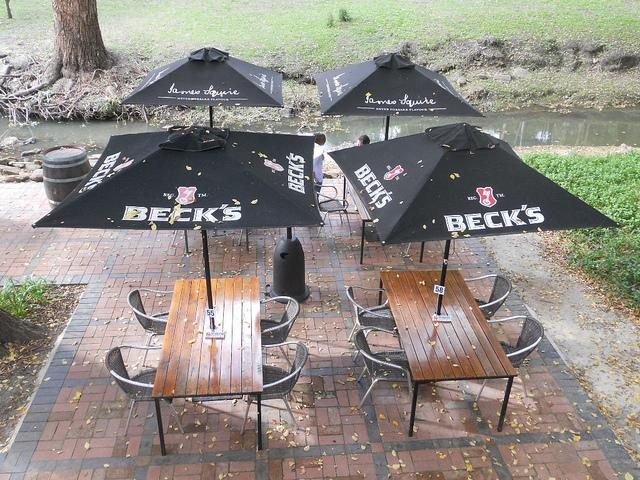What is this patio located next to? Please explain your reasoning. stream. This might also be called a creek in some areas of the world. 